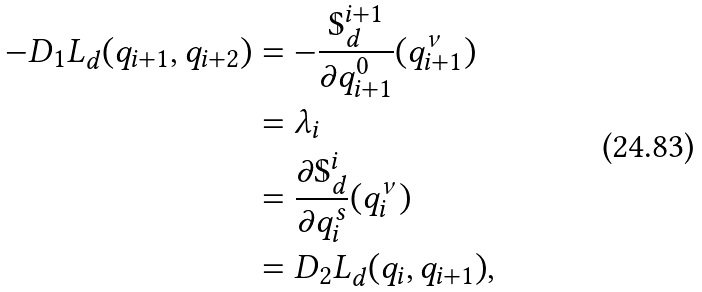Convert formula to latex. <formula><loc_0><loc_0><loc_500><loc_500>- D _ { 1 } L _ { d } ( q _ { i + 1 } , q _ { i + 2 } ) & = - \frac { \mathbb { S } _ { d } ^ { i + 1 } } { \partial q _ { i + 1 } ^ { 0 } } ( q _ { i + 1 } ^ { \nu } ) \\ & = \lambda _ { i } \\ & = \frac { \partial \mathbb { S } _ { d } ^ { i } } { \partial q _ { i } ^ { s } } ( q _ { i } ^ { \nu } ) \\ & = D _ { 2 } L _ { d } ( q _ { i } , q _ { i + 1 } ) ,</formula> 